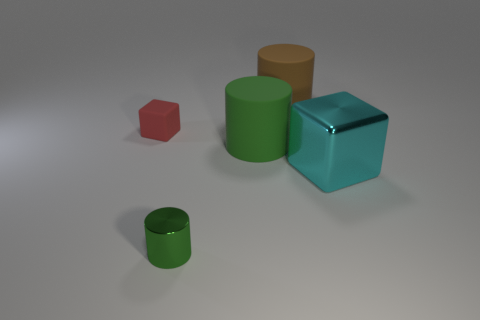Subtract all green cylinders. How many were subtracted if there are1green cylinders left? 1 Add 3 tiny green shiny objects. How many objects exist? 8 Subtract all cylinders. How many objects are left? 2 Add 2 red metallic cubes. How many red metallic cubes exist? 2 Subtract 0 brown spheres. How many objects are left? 5 Subtract all green matte cylinders. Subtract all large green matte cylinders. How many objects are left? 3 Add 4 shiny cylinders. How many shiny cylinders are left? 5 